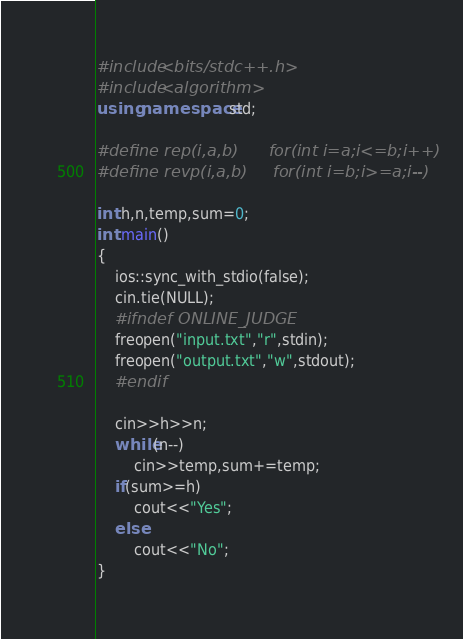Convert code to text. <code><loc_0><loc_0><loc_500><loc_500><_C++_>#include<bits/stdc++.h>
#include<algorithm>
using namespace std;

#define rep(i,a,b)      for(int i=a;i<=b;i++)
#define revp(i,a,b)     for(int i=b;i>=a;i--)

int h,n,temp,sum=0;
int main()
{
    ios::sync_with_stdio(false);
    cin.tie(NULL);
    #ifndef ONLINE_JUDGE
    freopen("input.txt","r",stdin);
    freopen("output.txt","w",stdout);
    #endif

    cin>>h>>n;
    while(n--)
        cin>>temp,sum+=temp;
    if(sum>=h)
        cout<<"Yes";
    else
        cout<<"No";
}


</code> 